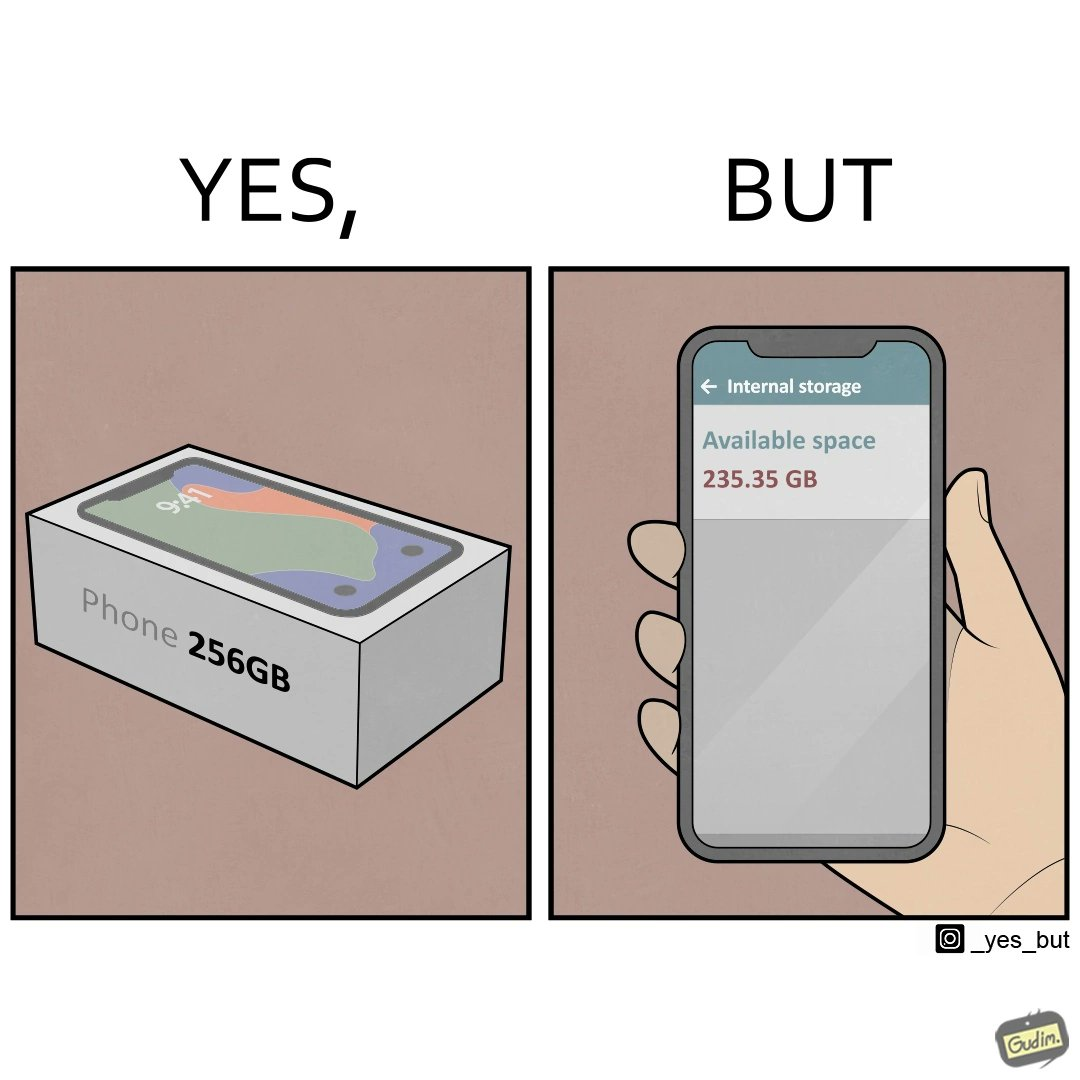Describe the content of this image. The images are funny since they show how smartphone manufacturers advertise their smartphones to have a high internal storage space but in reality, the amount of space available to an user is considerably less due to pre-installed software 